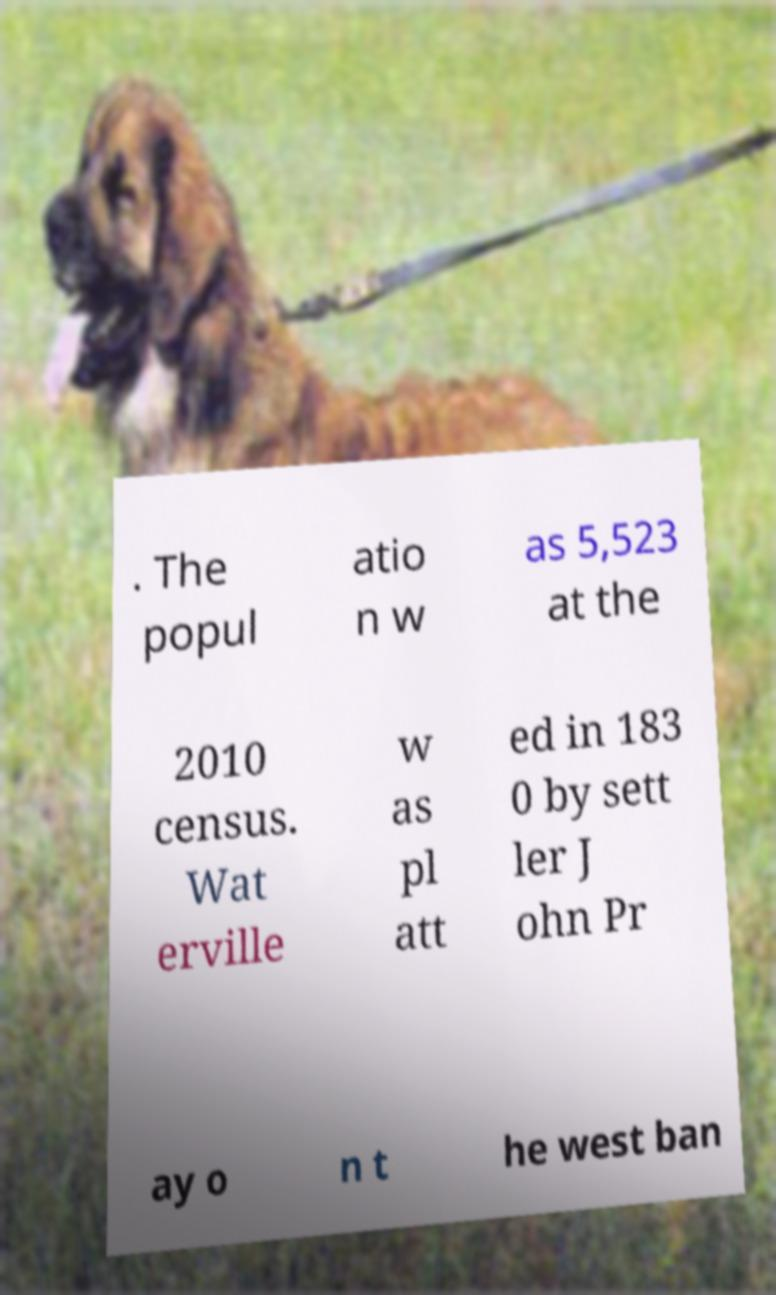Please read and relay the text visible in this image. What does it say? . The popul atio n w as 5,523 at the 2010 census. Wat erville w as pl att ed in 183 0 by sett ler J ohn Pr ay o n t he west ban 